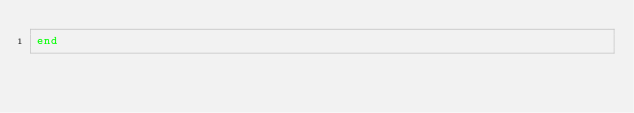Convert code to text. <code><loc_0><loc_0><loc_500><loc_500><_Ruby_>end
</code> 